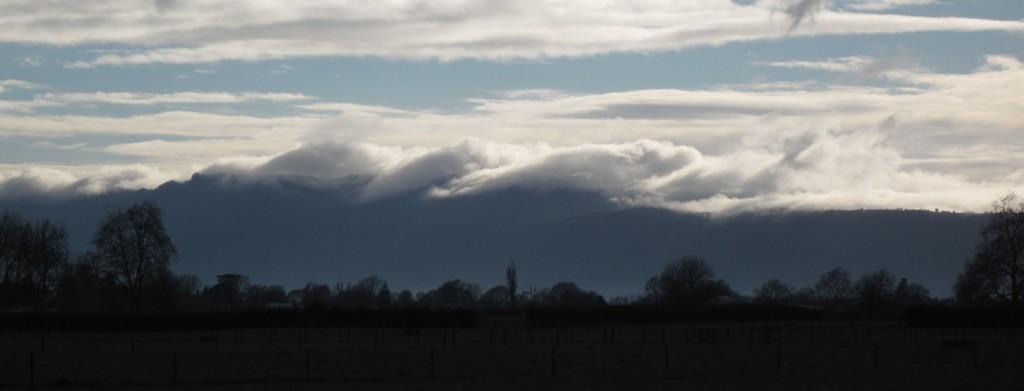What can be seen in the sky in the image? The sky with clouds is visible in the image. What type of vegetation is present in the image? There are trees in the image. What is the surface on which the trees and other objects are standing? The ground is visible in the image. How many ladybugs can be seen rolling on the ground in the image? There are no ladybugs or rolling objects present in the image. 